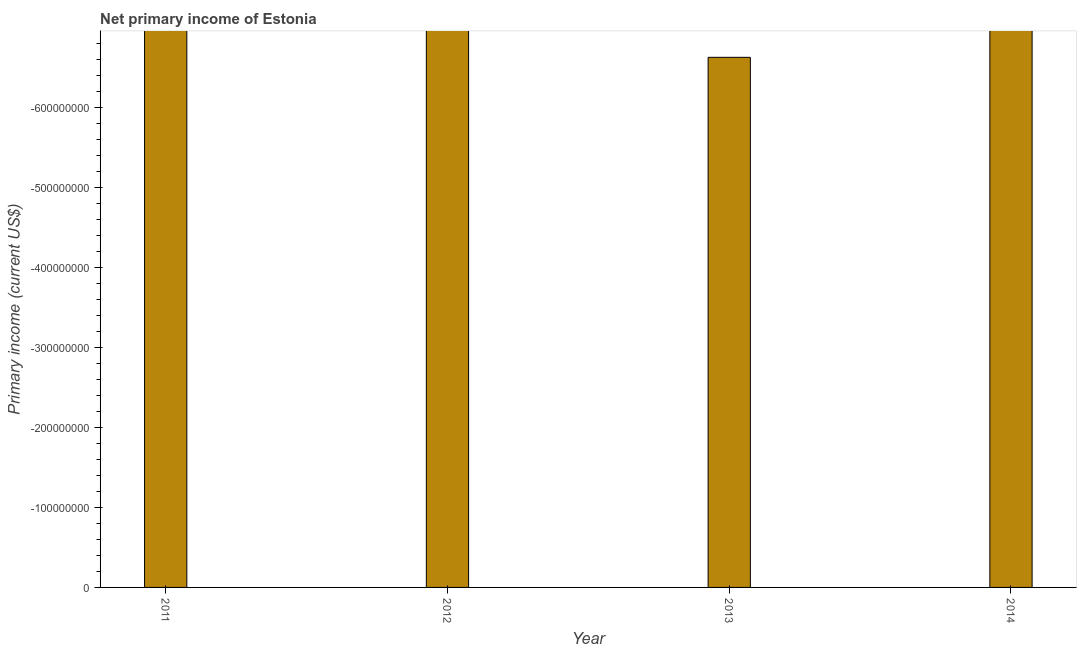Does the graph contain any zero values?
Ensure brevity in your answer.  Yes. What is the title of the graph?
Your answer should be compact. Net primary income of Estonia. What is the label or title of the X-axis?
Give a very brief answer. Year. What is the label or title of the Y-axis?
Give a very brief answer. Primary income (current US$). Across all years, what is the minimum amount of primary income?
Your answer should be very brief. 0. What is the average amount of primary income per year?
Give a very brief answer. 0. What is the median amount of primary income?
Keep it short and to the point. 0. Are all the bars in the graph horizontal?
Your answer should be compact. No. How many years are there in the graph?
Keep it short and to the point. 4. Are the values on the major ticks of Y-axis written in scientific E-notation?
Make the answer very short. No. What is the Primary income (current US$) of 2011?
Keep it short and to the point. 0. What is the Primary income (current US$) in 2013?
Provide a short and direct response. 0. What is the Primary income (current US$) of 2014?
Offer a very short reply. 0. 